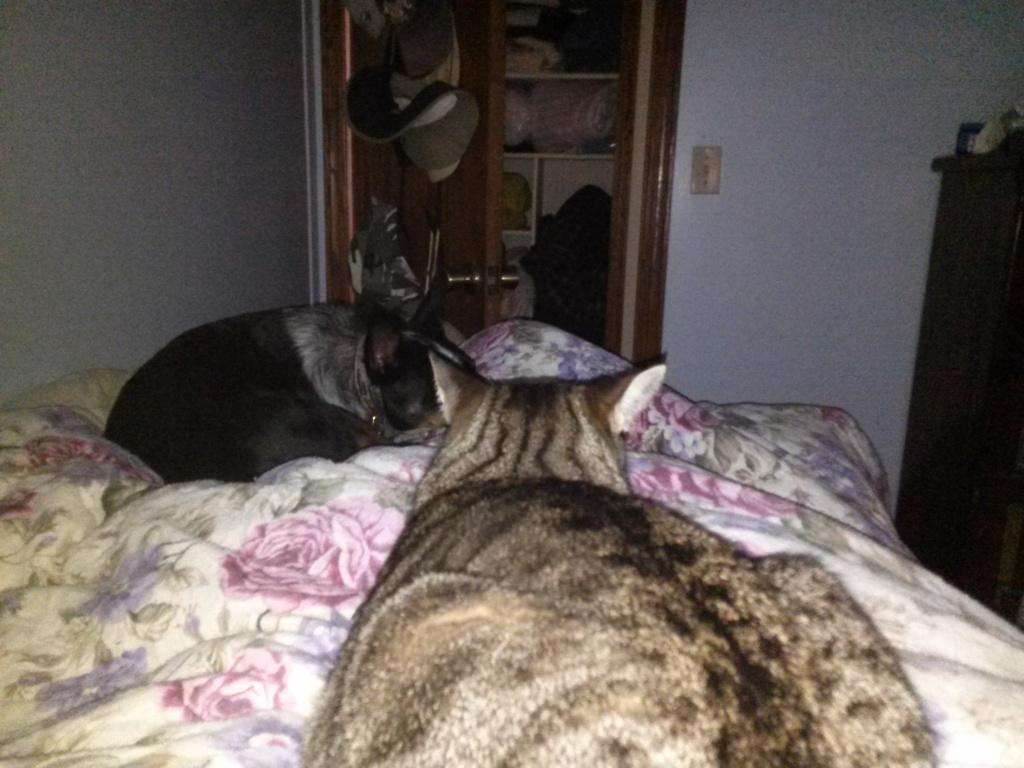What animals can be seen sleeping on the bed in the image? Cats are sleeping on the bed in the image. What type of furniture is present in the image? There is a cupboard in the image. What is the condition of the cupboard in the image? The cupboard is filled with things. What time does the clock on the bed show in the image? There is no clock present in the image. Can you see a duck swimming in the cupboard in the image? There is no duck present in the image. 